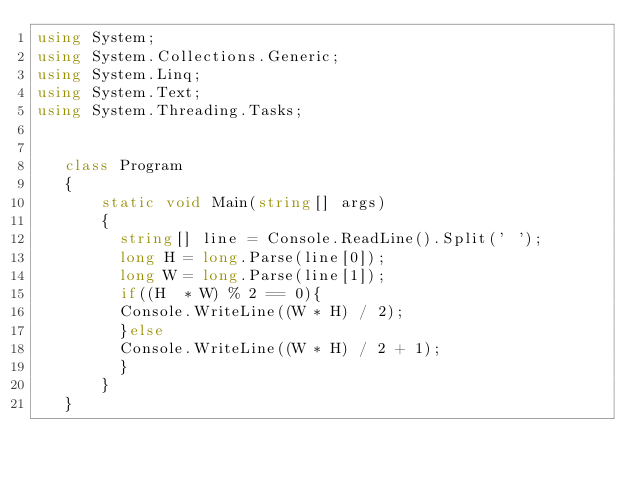Convert code to text. <code><loc_0><loc_0><loc_500><loc_500><_C#_>using System;
using System.Collections.Generic;
using System.Linq;
using System.Text;
using System.Threading.Tasks;


   class Program
   {
       static void Main(string[] args)
       {
         string[] line = Console.ReadLine().Split(' ');
         long H = long.Parse(line[0]);
         long W = long.Parse(line[1]);
         if((H  * W) % 2 == 0){
         Console.WriteLine((W * H) / 2);
         }else
         Console.WriteLine((W * H) / 2 + 1);
         }
       }
   }
</code> 